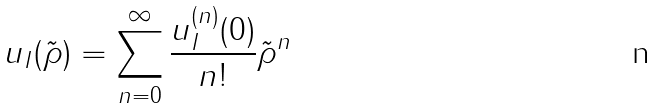Convert formula to latex. <formula><loc_0><loc_0><loc_500><loc_500>u _ { I } ( \tilde { \rho } ) = \sum _ { n = 0 } ^ { \infty } \frac { u _ { I } ^ { ( n ) } ( 0 ) } { n ! } \tilde { \rho } ^ { n }</formula> 